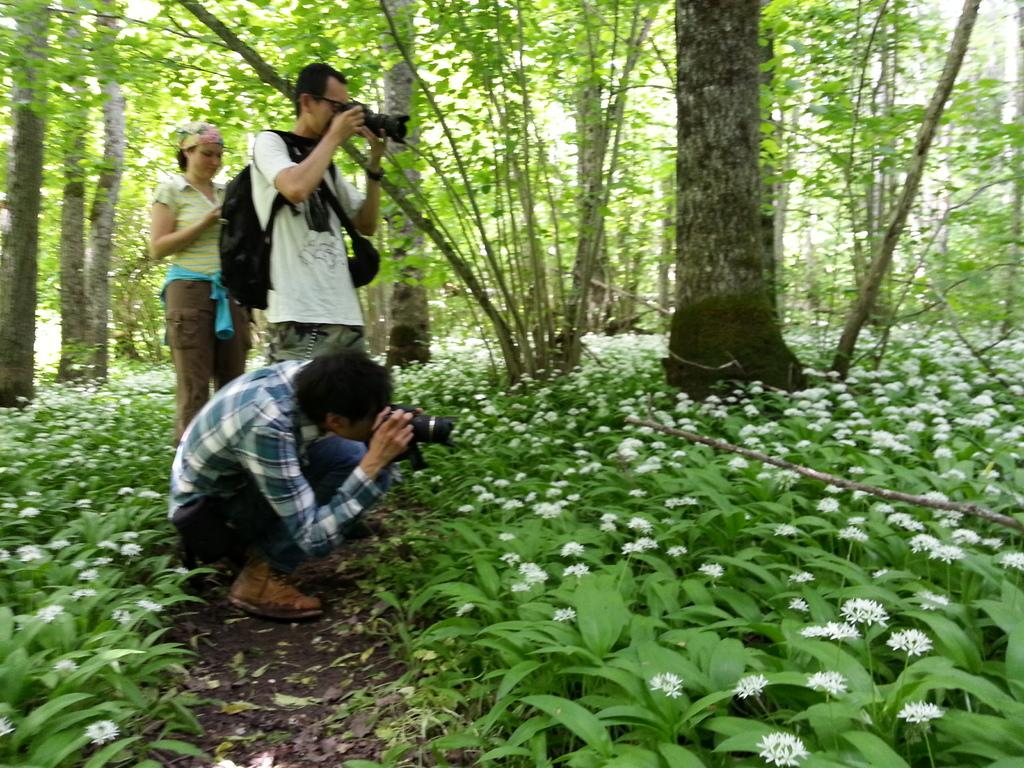What objects can be seen in the image? There are bags and flowers in the image. What type of vegetation is present in the image? There are plants in the image. What are the two people holding in their hands? They are holding cameras in their hands. What is the woman's position in the image? The woman is standing on the ground. What can be seen in the background of the image? There are trees in the background of the image. Who won the competition between the two people holding cameras in the image? There is no competition present in the image, so it is not possible to determine a winner. 